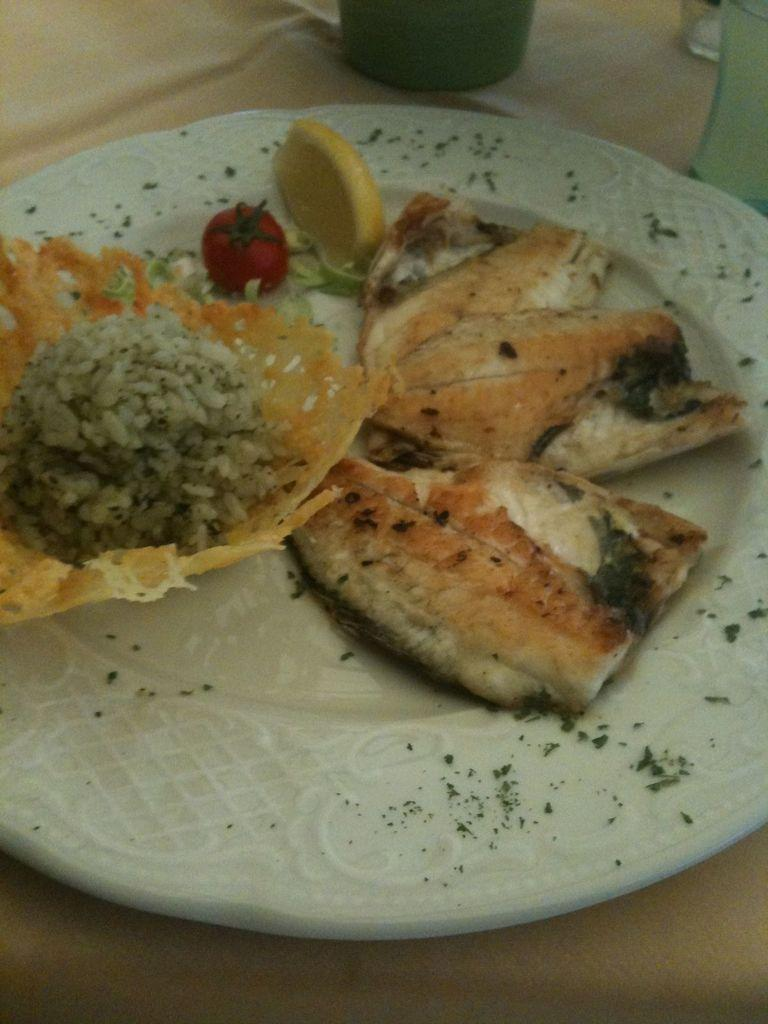What is on the plate in the image? There are food items on a plate in the image. Can you identify any specific garnish on the plate? Yes, there is a lemon slice in the image. What other fruit is present in the image? There is a tomato in the image. What type of container is visible in the image? There is a glass in the image. What else can be seen beside the glass? There is another object beside the glass in the image. What is the rate of quicksand in the image? There is no quicksand present in the image, so it is not possible to determine a rate. How many quinces are visible in the image? There are no quinces present in the image. 